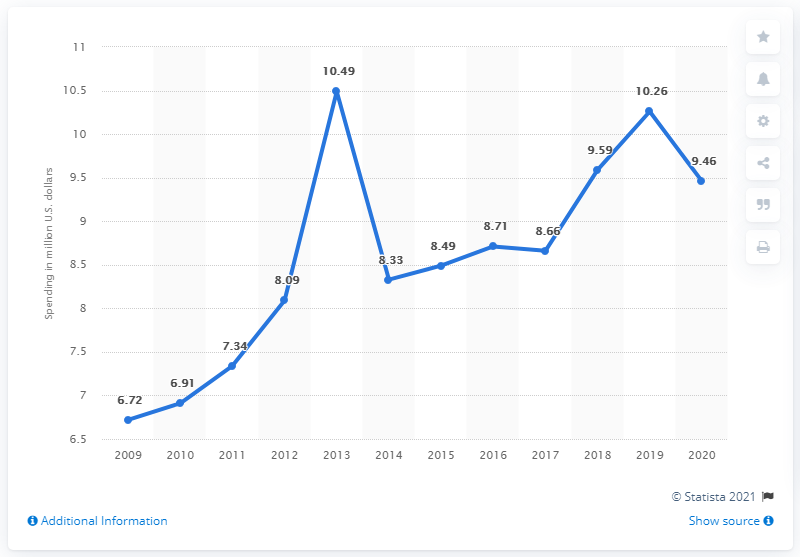List a handful of essential elements in this visual. In 2020, Microsoft spent 9.46 million dollars lobbying for the U.S. market. Microsoft spent approximately 9.46 U.S. dollars on lobbying in recent years. 